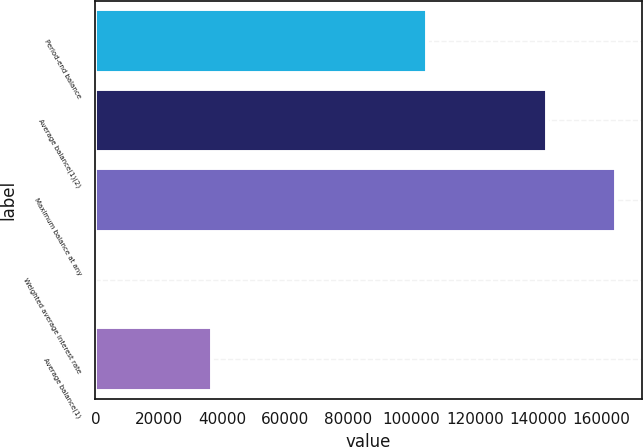Convert chart to OTSL. <chart><loc_0><loc_0><loc_500><loc_500><bar_chart><fcel>Period-end balance<fcel>Average balance(1)(2)<fcel>Maximum balance at any<fcel>Weighted average interest rate<fcel>Average balance(1)<nl><fcel>104800<fcel>142784<fcel>164511<fcel>0.8<fcel>36762<nl></chart> 